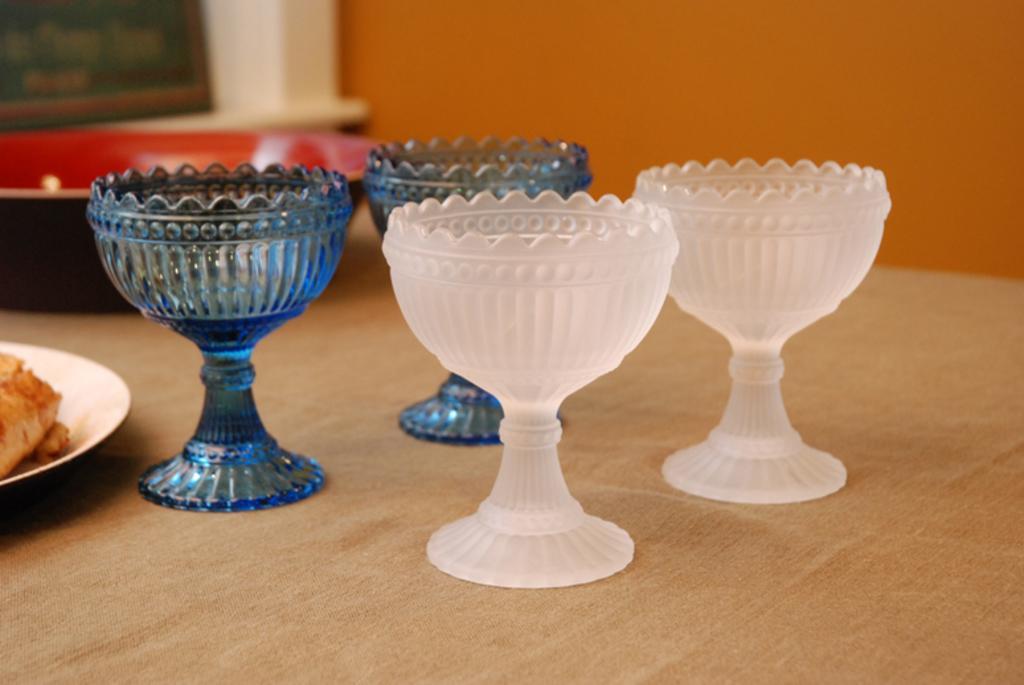Can you describe this image briefly? In this image there is a table on which there are two white glass cups and two blue glass cups. Behind them there is a bowl. On the left side there is a plate on which there is food. 